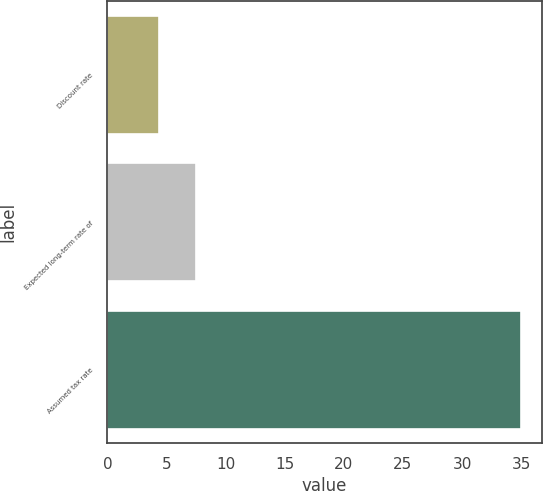<chart> <loc_0><loc_0><loc_500><loc_500><bar_chart><fcel>Discount rate<fcel>Expected long-term rate of<fcel>Assumed tax rate<nl><fcel>4.4<fcel>7.46<fcel>35<nl></chart> 